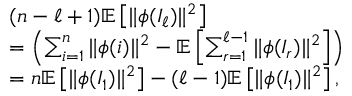Convert formula to latex. <formula><loc_0><loc_0><loc_500><loc_500>\begin{array} { r l } & { ( n - \ell + 1 ) \mathbb { E } \left [ \| \phi ( I _ { \ell } ) \| ^ { 2 } \right ] } \\ & { = \left ( \sum _ { i = 1 } ^ { n } \| \phi ( i ) \| ^ { 2 } - \mathbb { E } \left [ \sum _ { r = 1 } ^ { \ell - 1 } \| \phi ( I _ { r } ) \| ^ { 2 } \right ] \right ) } \\ & { = n \mathbb { E } \left [ \| \phi ( I _ { 1 } ) \| ^ { 2 } \right ] - ( \ell - 1 ) \mathbb { E } \left [ \| \phi ( I _ { 1 } ) \| ^ { 2 } \right ] , } \end{array}</formula> 